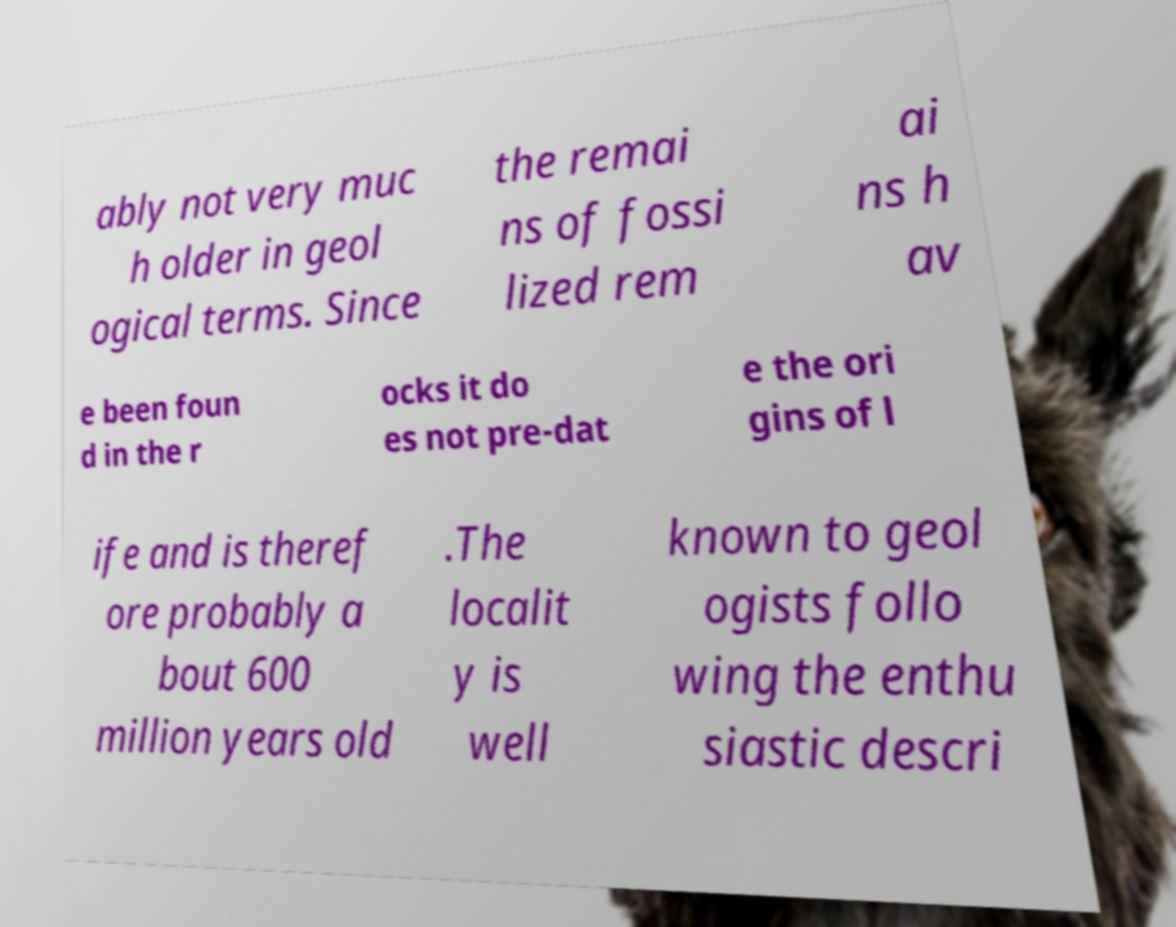Can you read and provide the text displayed in the image?This photo seems to have some interesting text. Can you extract and type it out for me? ably not very muc h older in geol ogical terms. Since the remai ns of fossi lized rem ai ns h av e been foun d in the r ocks it do es not pre-dat e the ori gins of l ife and is theref ore probably a bout 600 million years old .The localit y is well known to geol ogists follo wing the enthu siastic descri 